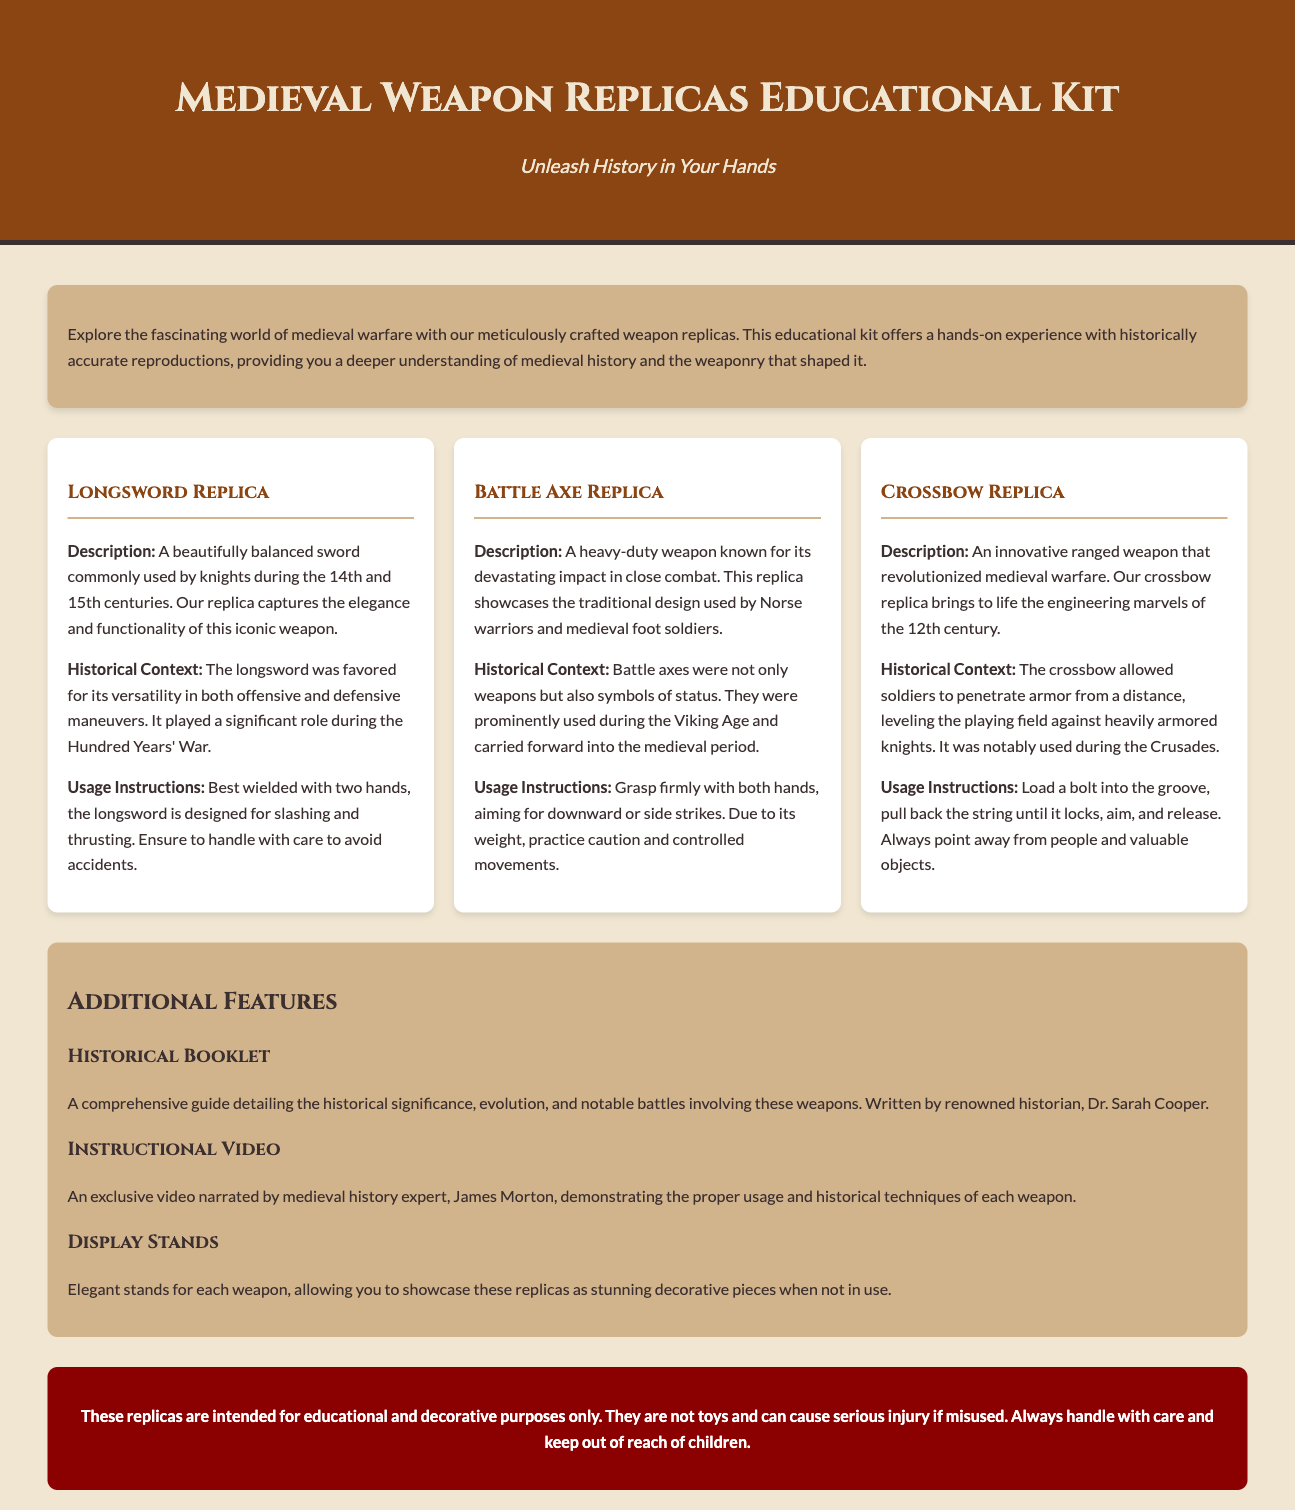What is the title of the kit? The title of the kit is prominently displayed in the header of the document.
Answer: Medieval Weapon Replicas Educational Kit Who wrote the historical booklet? The document mentions the author of the historical booklet in the additional features section.
Answer: Dr. Sarah Cooper What innovative weapon is discussed in the kit? The kit describes a specific type of weapon in the content, highlighting its uniqueness.
Answer: Crossbow What material is the safety warning background? The safety warning section specifies the color representing its significance.
Answer: Dark red Which feature includes a video demonstration? The additional features section lists different features, one being a video demonstration.
Answer: Instructional Video How many main weapon replicas are featured in the kit? The document lists the number of weapon replicas in the weapon grid section.
Answer: Three What is the purpose of the display stands? The function of the display stands is described in the additional features section.
Answer: Showcasing replicas During which century was the longsword commonly used? The historical context section for the longsword replica states the century of its usage.
Answer: 14th and 15th centuries What is the primary instructional note for using the battle axe? The usage instructions for the battle axe highlight a key handling advice.
Answer: Grasp firmly with both hands 